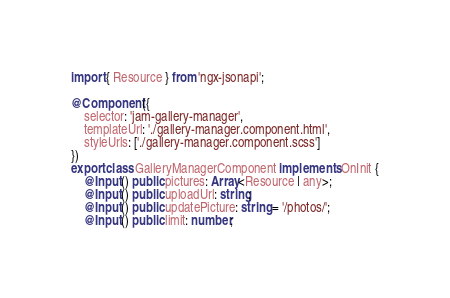Convert code to text. <code><loc_0><loc_0><loc_500><loc_500><_TypeScript_>import { Resource } from 'ngx-jsonapi';

@Component({
    selector: 'jam-gallery-manager',
    templateUrl: './gallery-manager.component.html',
    styleUrls: ['./gallery-manager.component.scss']
})
export class GalleryManagerComponent implements OnInit {
    @Input() public pictures: Array<Resource | any>;
    @Input() public uploadUrl: string;
    @Input() public updatePicture: string = '/photos/';
    @Input() public limit: number;</code> 